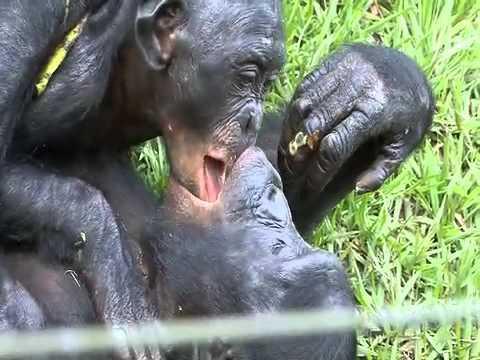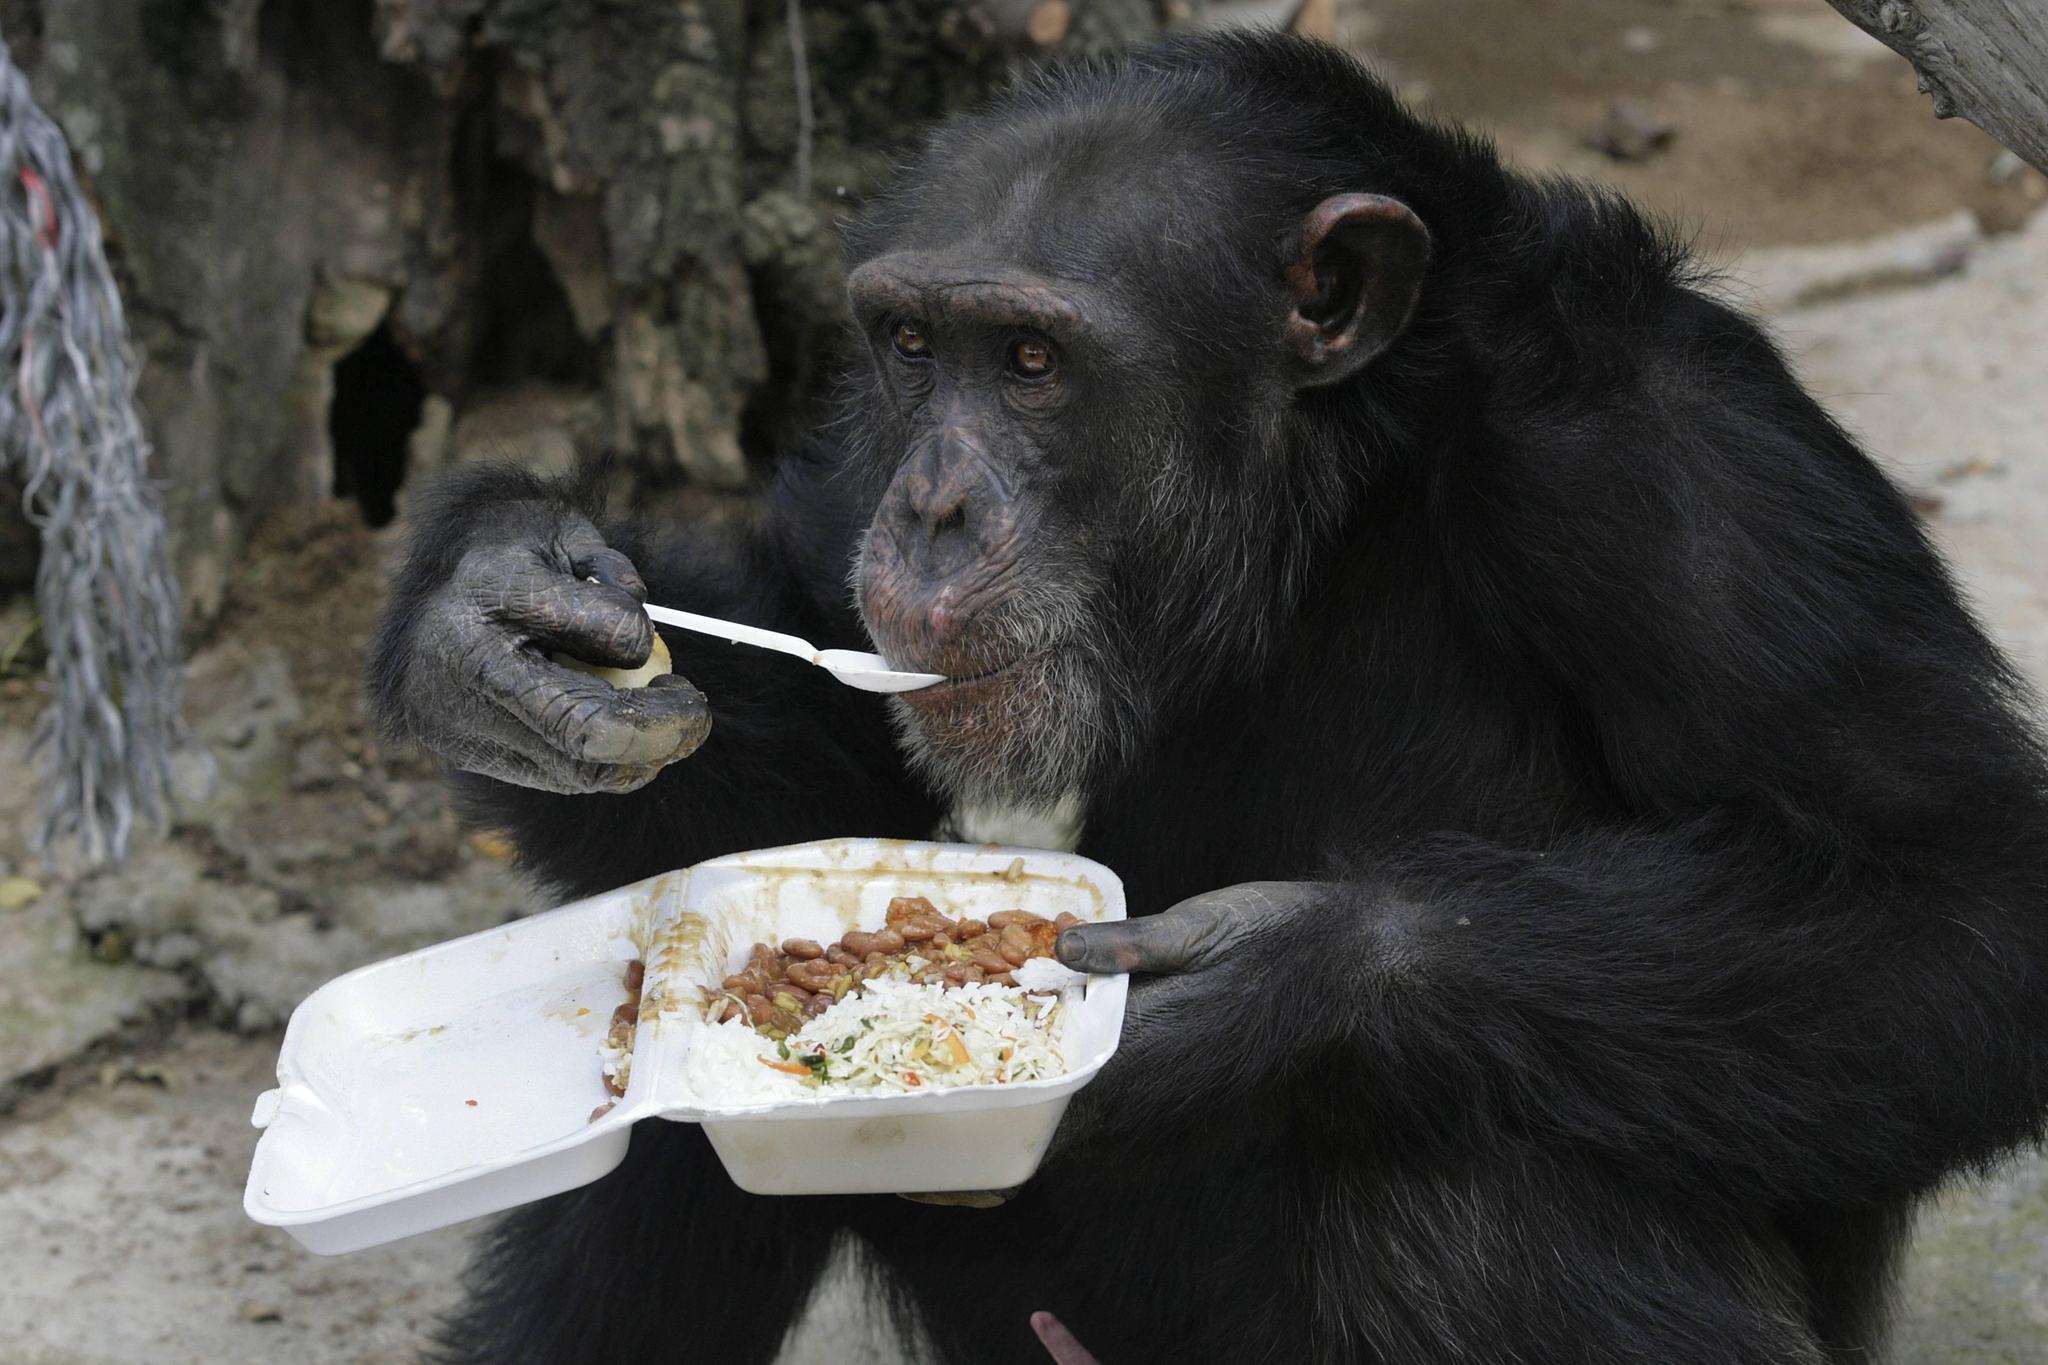The first image is the image on the left, the second image is the image on the right. Evaluate the accuracy of this statement regarding the images: "In one of the pictures, two primates kissing each other on the lips, and in the other, a baby primate is next to an adult.". Is it true? Answer yes or no. No. The first image is the image on the left, the second image is the image on the right. For the images displayed, is the sentence "Both images show a pair of chimps with their mouths very close together." factually correct? Answer yes or no. No. 